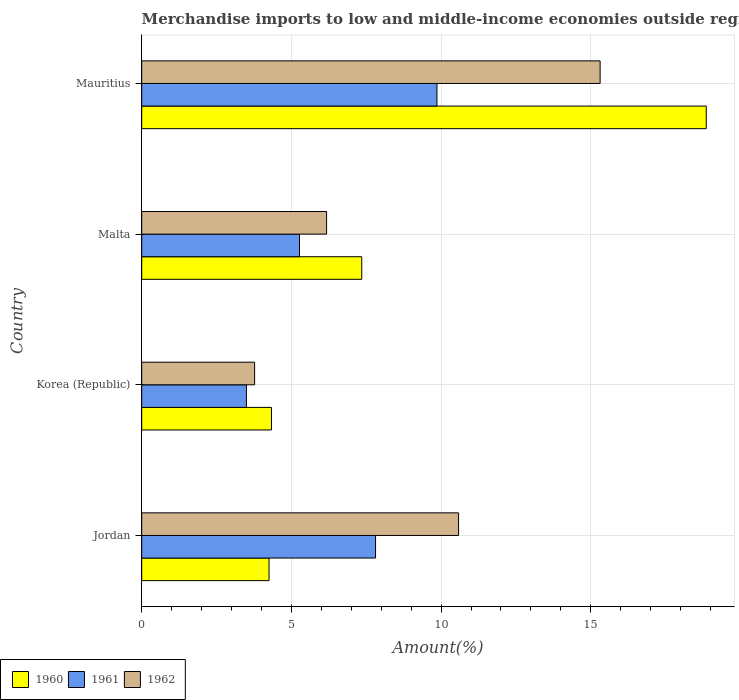How many bars are there on the 3rd tick from the bottom?
Your answer should be compact. 3. In how many cases, is the number of bars for a given country not equal to the number of legend labels?
Offer a very short reply. 0. What is the percentage of amount earned from merchandise imports in 1961 in Jordan?
Keep it short and to the point. 7.81. Across all countries, what is the maximum percentage of amount earned from merchandise imports in 1960?
Offer a very short reply. 18.86. Across all countries, what is the minimum percentage of amount earned from merchandise imports in 1961?
Offer a terse response. 3.5. In which country was the percentage of amount earned from merchandise imports in 1960 maximum?
Keep it short and to the point. Mauritius. What is the total percentage of amount earned from merchandise imports in 1961 in the graph?
Provide a succinct answer. 26.44. What is the difference between the percentage of amount earned from merchandise imports in 1960 in Korea (Republic) and that in Malta?
Your answer should be compact. -3.02. What is the difference between the percentage of amount earned from merchandise imports in 1960 in Mauritius and the percentage of amount earned from merchandise imports in 1962 in Korea (Republic)?
Keep it short and to the point. 15.09. What is the average percentage of amount earned from merchandise imports in 1961 per country?
Offer a terse response. 6.61. What is the difference between the percentage of amount earned from merchandise imports in 1961 and percentage of amount earned from merchandise imports in 1960 in Malta?
Ensure brevity in your answer.  -2.08. What is the ratio of the percentage of amount earned from merchandise imports in 1962 in Korea (Republic) to that in Malta?
Provide a succinct answer. 0.61. What is the difference between the highest and the second highest percentage of amount earned from merchandise imports in 1962?
Keep it short and to the point. 4.73. What is the difference between the highest and the lowest percentage of amount earned from merchandise imports in 1961?
Make the answer very short. 6.37. In how many countries, is the percentage of amount earned from merchandise imports in 1960 greater than the average percentage of amount earned from merchandise imports in 1960 taken over all countries?
Give a very brief answer. 1. Is the sum of the percentage of amount earned from merchandise imports in 1960 in Malta and Mauritius greater than the maximum percentage of amount earned from merchandise imports in 1961 across all countries?
Give a very brief answer. Yes. What does the 3rd bar from the top in Mauritius represents?
Make the answer very short. 1960. What does the 2nd bar from the bottom in Mauritius represents?
Provide a short and direct response. 1961. Is it the case that in every country, the sum of the percentage of amount earned from merchandise imports in 1962 and percentage of amount earned from merchandise imports in 1960 is greater than the percentage of amount earned from merchandise imports in 1961?
Your answer should be very brief. Yes. Are all the bars in the graph horizontal?
Ensure brevity in your answer.  Yes. How many countries are there in the graph?
Make the answer very short. 4. What is the difference between two consecutive major ticks on the X-axis?
Ensure brevity in your answer.  5. Are the values on the major ticks of X-axis written in scientific E-notation?
Your answer should be compact. No. How many legend labels are there?
Provide a succinct answer. 3. How are the legend labels stacked?
Offer a very short reply. Horizontal. What is the title of the graph?
Ensure brevity in your answer.  Merchandise imports to low and middle-income economies outside region. What is the label or title of the X-axis?
Your answer should be compact. Amount(%). What is the Amount(%) of 1960 in Jordan?
Your answer should be very brief. 4.25. What is the Amount(%) in 1961 in Jordan?
Your answer should be very brief. 7.81. What is the Amount(%) of 1962 in Jordan?
Offer a very short reply. 10.58. What is the Amount(%) of 1960 in Korea (Republic)?
Give a very brief answer. 4.33. What is the Amount(%) of 1961 in Korea (Republic)?
Provide a succinct answer. 3.5. What is the Amount(%) of 1962 in Korea (Republic)?
Provide a short and direct response. 3.77. What is the Amount(%) in 1960 in Malta?
Make the answer very short. 7.35. What is the Amount(%) in 1961 in Malta?
Your answer should be compact. 5.27. What is the Amount(%) in 1962 in Malta?
Offer a terse response. 6.18. What is the Amount(%) in 1960 in Mauritius?
Offer a terse response. 18.86. What is the Amount(%) in 1961 in Mauritius?
Your response must be concise. 9.86. What is the Amount(%) in 1962 in Mauritius?
Provide a succinct answer. 15.31. Across all countries, what is the maximum Amount(%) of 1960?
Provide a succinct answer. 18.86. Across all countries, what is the maximum Amount(%) of 1961?
Your answer should be compact. 9.86. Across all countries, what is the maximum Amount(%) of 1962?
Offer a very short reply. 15.31. Across all countries, what is the minimum Amount(%) in 1960?
Offer a terse response. 4.25. Across all countries, what is the minimum Amount(%) of 1961?
Give a very brief answer. 3.5. Across all countries, what is the minimum Amount(%) in 1962?
Provide a succinct answer. 3.77. What is the total Amount(%) in 1960 in the graph?
Ensure brevity in your answer.  34.8. What is the total Amount(%) of 1961 in the graph?
Give a very brief answer. 26.44. What is the total Amount(%) in 1962 in the graph?
Offer a terse response. 35.84. What is the difference between the Amount(%) in 1960 in Jordan and that in Korea (Republic)?
Ensure brevity in your answer.  -0.08. What is the difference between the Amount(%) of 1961 in Jordan and that in Korea (Republic)?
Offer a terse response. 4.31. What is the difference between the Amount(%) in 1962 in Jordan and that in Korea (Republic)?
Offer a very short reply. 6.81. What is the difference between the Amount(%) in 1960 in Jordan and that in Malta?
Offer a very short reply. -3.1. What is the difference between the Amount(%) of 1961 in Jordan and that in Malta?
Your response must be concise. 2.54. What is the difference between the Amount(%) of 1962 in Jordan and that in Malta?
Your answer should be very brief. 4.41. What is the difference between the Amount(%) in 1960 in Jordan and that in Mauritius?
Keep it short and to the point. -14.61. What is the difference between the Amount(%) of 1961 in Jordan and that in Mauritius?
Offer a very short reply. -2.05. What is the difference between the Amount(%) of 1962 in Jordan and that in Mauritius?
Your answer should be compact. -4.73. What is the difference between the Amount(%) in 1960 in Korea (Republic) and that in Malta?
Your answer should be compact. -3.02. What is the difference between the Amount(%) of 1961 in Korea (Republic) and that in Malta?
Your answer should be very brief. -1.77. What is the difference between the Amount(%) of 1962 in Korea (Republic) and that in Malta?
Your answer should be very brief. -2.4. What is the difference between the Amount(%) of 1960 in Korea (Republic) and that in Mauritius?
Ensure brevity in your answer.  -14.53. What is the difference between the Amount(%) of 1961 in Korea (Republic) and that in Mauritius?
Offer a terse response. -6.37. What is the difference between the Amount(%) in 1962 in Korea (Republic) and that in Mauritius?
Give a very brief answer. -11.54. What is the difference between the Amount(%) of 1960 in Malta and that in Mauritius?
Provide a succinct answer. -11.51. What is the difference between the Amount(%) in 1961 in Malta and that in Mauritius?
Your answer should be compact. -4.59. What is the difference between the Amount(%) in 1962 in Malta and that in Mauritius?
Offer a very short reply. -9.14. What is the difference between the Amount(%) in 1960 in Jordan and the Amount(%) in 1961 in Korea (Republic)?
Offer a very short reply. 0.76. What is the difference between the Amount(%) of 1960 in Jordan and the Amount(%) of 1962 in Korea (Republic)?
Keep it short and to the point. 0.48. What is the difference between the Amount(%) in 1961 in Jordan and the Amount(%) in 1962 in Korea (Republic)?
Your response must be concise. 4.04. What is the difference between the Amount(%) of 1960 in Jordan and the Amount(%) of 1961 in Malta?
Your answer should be very brief. -1.02. What is the difference between the Amount(%) of 1960 in Jordan and the Amount(%) of 1962 in Malta?
Ensure brevity in your answer.  -1.92. What is the difference between the Amount(%) in 1961 in Jordan and the Amount(%) in 1962 in Malta?
Your answer should be compact. 1.64. What is the difference between the Amount(%) of 1960 in Jordan and the Amount(%) of 1961 in Mauritius?
Your answer should be very brief. -5.61. What is the difference between the Amount(%) in 1960 in Jordan and the Amount(%) in 1962 in Mauritius?
Ensure brevity in your answer.  -11.06. What is the difference between the Amount(%) of 1961 in Jordan and the Amount(%) of 1962 in Mauritius?
Provide a succinct answer. -7.5. What is the difference between the Amount(%) of 1960 in Korea (Republic) and the Amount(%) of 1961 in Malta?
Ensure brevity in your answer.  -0.94. What is the difference between the Amount(%) of 1960 in Korea (Republic) and the Amount(%) of 1962 in Malta?
Your answer should be compact. -1.84. What is the difference between the Amount(%) of 1961 in Korea (Republic) and the Amount(%) of 1962 in Malta?
Offer a very short reply. -2.68. What is the difference between the Amount(%) in 1960 in Korea (Republic) and the Amount(%) in 1961 in Mauritius?
Make the answer very short. -5.53. What is the difference between the Amount(%) of 1960 in Korea (Republic) and the Amount(%) of 1962 in Mauritius?
Your answer should be very brief. -10.98. What is the difference between the Amount(%) in 1961 in Korea (Republic) and the Amount(%) in 1962 in Mauritius?
Your answer should be compact. -11.82. What is the difference between the Amount(%) of 1960 in Malta and the Amount(%) of 1961 in Mauritius?
Ensure brevity in your answer.  -2.51. What is the difference between the Amount(%) in 1960 in Malta and the Amount(%) in 1962 in Mauritius?
Ensure brevity in your answer.  -7.96. What is the difference between the Amount(%) in 1961 in Malta and the Amount(%) in 1962 in Mauritius?
Your answer should be very brief. -10.04. What is the average Amount(%) of 1960 per country?
Your response must be concise. 8.7. What is the average Amount(%) in 1961 per country?
Your response must be concise. 6.61. What is the average Amount(%) in 1962 per country?
Ensure brevity in your answer.  8.96. What is the difference between the Amount(%) in 1960 and Amount(%) in 1961 in Jordan?
Your response must be concise. -3.56. What is the difference between the Amount(%) in 1960 and Amount(%) in 1962 in Jordan?
Offer a terse response. -6.33. What is the difference between the Amount(%) in 1961 and Amount(%) in 1962 in Jordan?
Keep it short and to the point. -2.77. What is the difference between the Amount(%) in 1960 and Amount(%) in 1961 in Korea (Republic)?
Your response must be concise. 0.84. What is the difference between the Amount(%) in 1960 and Amount(%) in 1962 in Korea (Republic)?
Your answer should be very brief. 0.56. What is the difference between the Amount(%) in 1961 and Amount(%) in 1962 in Korea (Republic)?
Provide a succinct answer. -0.27. What is the difference between the Amount(%) in 1960 and Amount(%) in 1961 in Malta?
Give a very brief answer. 2.08. What is the difference between the Amount(%) of 1960 and Amount(%) of 1962 in Malta?
Ensure brevity in your answer.  1.17. What is the difference between the Amount(%) of 1961 and Amount(%) of 1962 in Malta?
Keep it short and to the point. -0.9. What is the difference between the Amount(%) in 1960 and Amount(%) in 1961 in Mauritius?
Offer a very short reply. 9. What is the difference between the Amount(%) in 1960 and Amount(%) in 1962 in Mauritius?
Your response must be concise. 3.55. What is the difference between the Amount(%) of 1961 and Amount(%) of 1962 in Mauritius?
Your answer should be compact. -5.45. What is the ratio of the Amount(%) of 1960 in Jordan to that in Korea (Republic)?
Your answer should be very brief. 0.98. What is the ratio of the Amount(%) of 1961 in Jordan to that in Korea (Republic)?
Offer a very short reply. 2.23. What is the ratio of the Amount(%) of 1962 in Jordan to that in Korea (Republic)?
Your answer should be compact. 2.81. What is the ratio of the Amount(%) of 1960 in Jordan to that in Malta?
Your response must be concise. 0.58. What is the ratio of the Amount(%) in 1961 in Jordan to that in Malta?
Your answer should be compact. 1.48. What is the ratio of the Amount(%) in 1962 in Jordan to that in Malta?
Ensure brevity in your answer.  1.71. What is the ratio of the Amount(%) in 1960 in Jordan to that in Mauritius?
Ensure brevity in your answer.  0.23. What is the ratio of the Amount(%) in 1961 in Jordan to that in Mauritius?
Provide a short and direct response. 0.79. What is the ratio of the Amount(%) of 1962 in Jordan to that in Mauritius?
Your response must be concise. 0.69. What is the ratio of the Amount(%) of 1960 in Korea (Republic) to that in Malta?
Keep it short and to the point. 0.59. What is the ratio of the Amount(%) in 1961 in Korea (Republic) to that in Malta?
Your answer should be compact. 0.66. What is the ratio of the Amount(%) of 1962 in Korea (Republic) to that in Malta?
Give a very brief answer. 0.61. What is the ratio of the Amount(%) in 1960 in Korea (Republic) to that in Mauritius?
Offer a terse response. 0.23. What is the ratio of the Amount(%) in 1961 in Korea (Republic) to that in Mauritius?
Offer a terse response. 0.35. What is the ratio of the Amount(%) of 1962 in Korea (Republic) to that in Mauritius?
Provide a succinct answer. 0.25. What is the ratio of the Amount(%) in 1960 in Malta to that in Mauritius?
Offer a terse response. 0.39. What is the ratio of the Amount(%) of 1961 in Malta to that in Mauritius?
Your answer should be compact. 0.53. What is the ratio of the Amount(%) of 1962 in Malta to that in Mauritius?
Keep it short and to the point. 0.4. What is the difference between the highest and the second highest Amount(%) in 1960?
Your response must be concise. 11.51. What is the difference between the highest and the second highest Amount(%) of 1961?
Offer a very short reply. 2.05. What is the difference between the highest and the second highest Amount(%) in 1962?
Make the answer very short. 4.73. What is the difference between the highest and the lowest Amount(%) of 1960?
Your response must be concise. 14.61. What is the difference between the highest and the lowest Amount(%) of 1961?
Your response must be concise. 6.37. What is the difference between the highest and the lowest Amount(%) in 1962?
Keep it short and to the point. 11.54. 